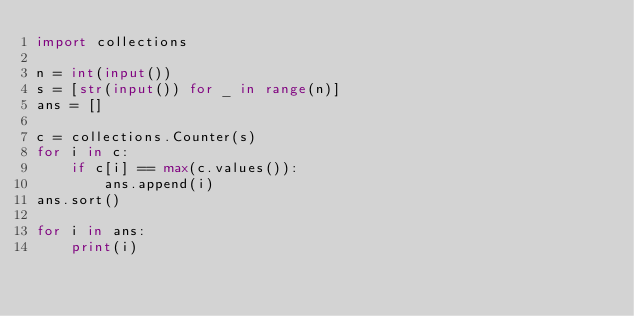Convert code to text. <code><loc_0><loc_0><loc_500><loc_500><_Python_>import collections

n = int(input())
s = [str(input()) for _ in range(n)]
ans = []

c = collections.Counter(s)
for i in c:
    if c[i] == max(c.values()):
        ans.append(i)
ans.sort()

for i in ans:
    print(i)</code> 